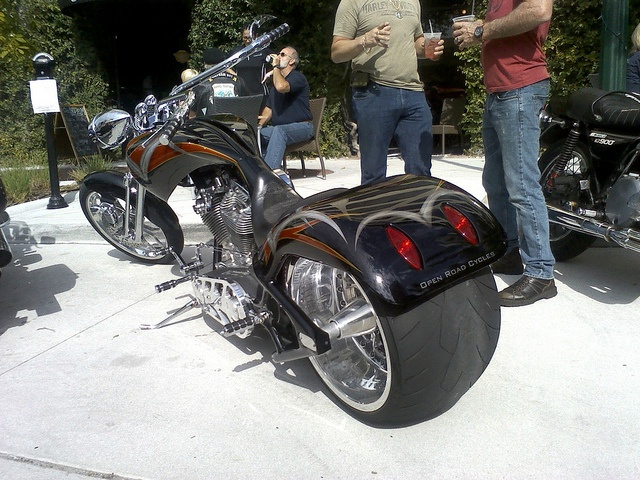Describe the objects in this image and their specific colors. I can see motorcycle in darkgreen, black, gray, darkgray, and lightgray tones, people in darkgreen, gray, black, maroon, and brown tones, motorcycle in darkgreen, black, gray, darkgray, and purple tones, people in darkgreen, darkgray, darkblue, and black tones, and people in darkgreen, black, and gray tones in this image. 